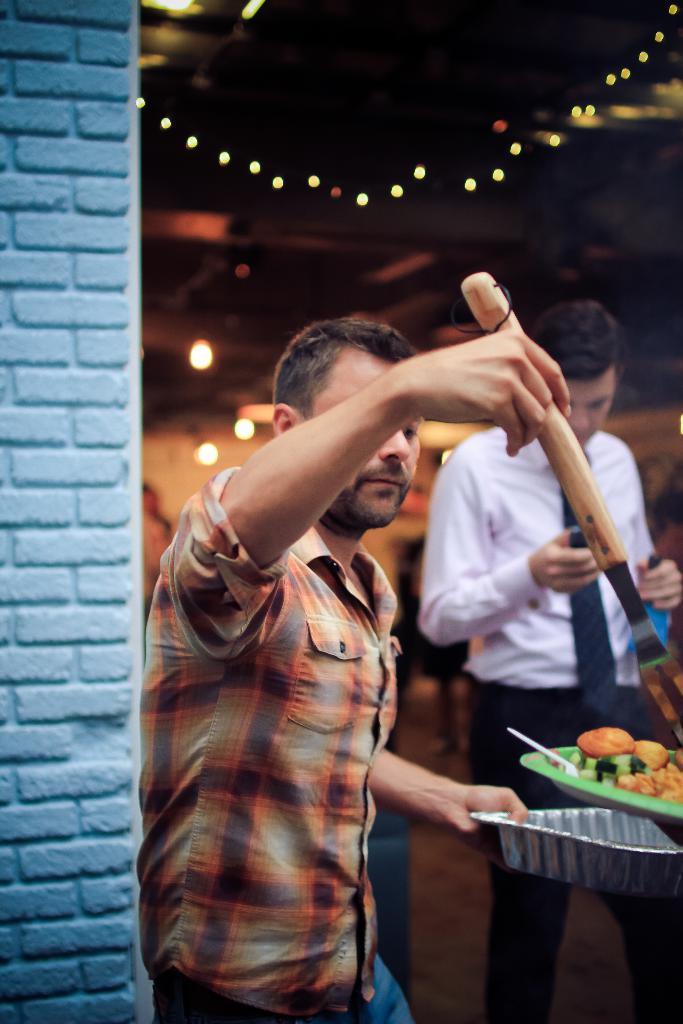Could you give a brief overview of what you see in this image? In this image we can see two persons a person is holding a bowl and an object and there is a plate with food items and a spoon there is a wall behind the person and lights in the background. 